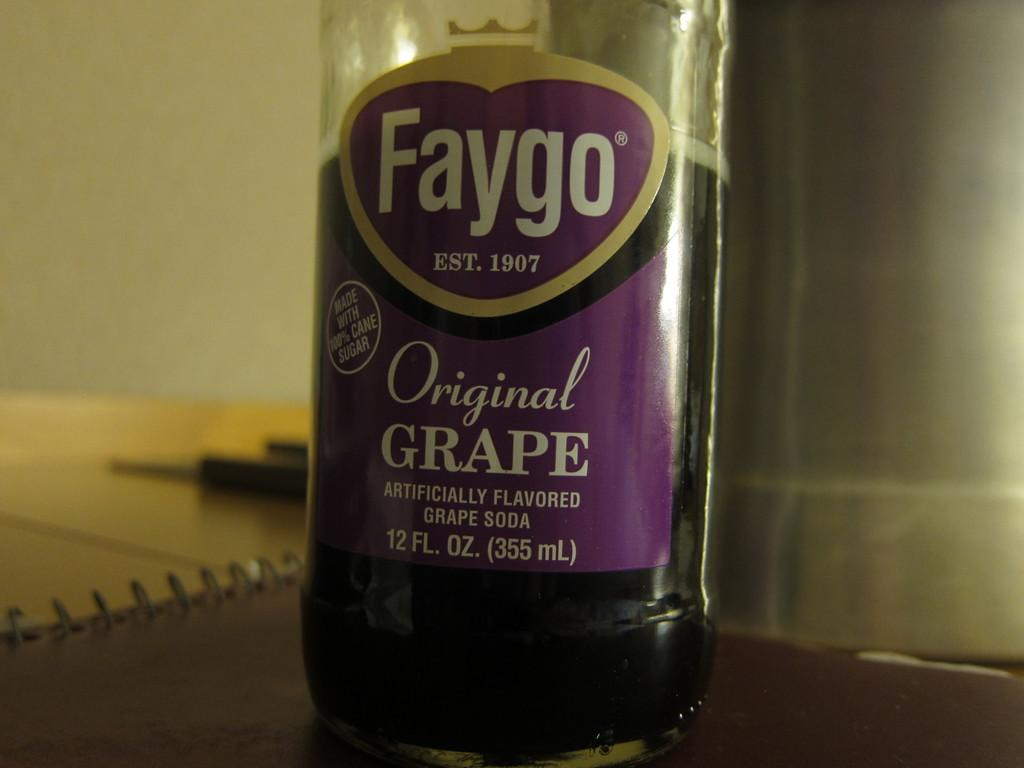<image>
Relay a brief, clear account of the picture shown. A Faygo brand grape soda bottle is about half empty. 